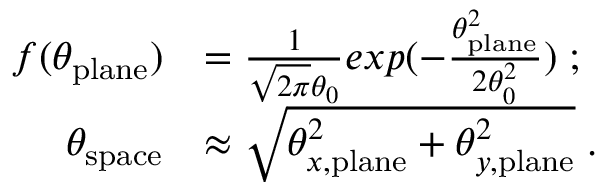Convert formula to latex. <formula><loc_0><loc_0><loc_500><loc_500>\begin{array} { r l } { f ( \theta _ { p l a n e } ) } & { = \frac { 1 } { \sqrt { 2 \pi } \theta _ { 0 } } e x p ( - \frac { \theta _ { p l a n e } ^ { 2 } } { 2 \theta _ { 0 } ^ { 2 } } ) \, ; } \\ { \theta _ { s p a c e } } & { \approx \sqrt { \theta _ { x , p l a n e } ^ { 2 } + \theta _ { y , p l a n e } ^ { 2 } } \, . } \end{array}</formula> 